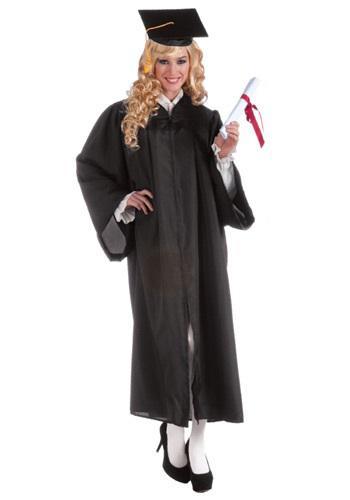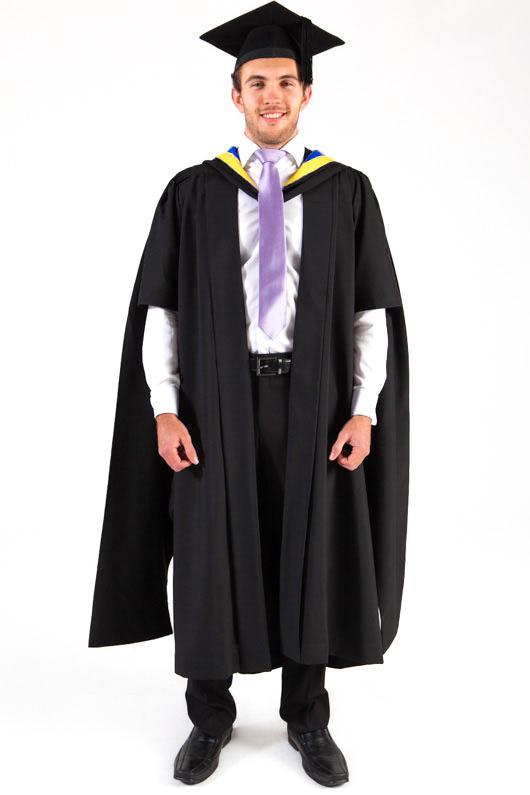The first image is the image on the left, the second image is the image on the right. Analyze the images presented: Is the assertion "A woman stands with one hand on her hip." valid? Answer yes or no. Yes. The first image is the image on the left, the second image is the image on the right. Considering the images on both sides, is "The student in the right image is wearing a purple tie." valid? Answer yes or no. Yes. 